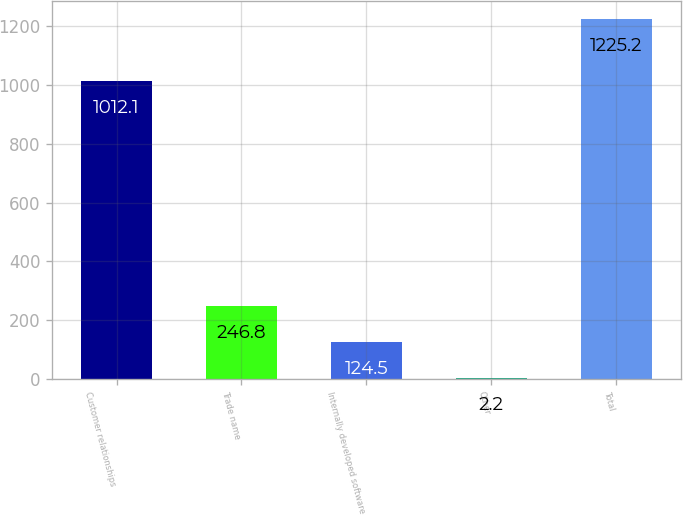Convert chart. <chart><loc_0><loc_0><loc_500><loc_500><bar_chart><fcel>Customer relationships<fcel>Trade name<fcel>Internally developed software<fcel>Other<fcel>Total<nl><fcel>1012.1<fcel>246.8<fcel>124.5<fcel>2.2<fcel>1225.2<nl></chart> 